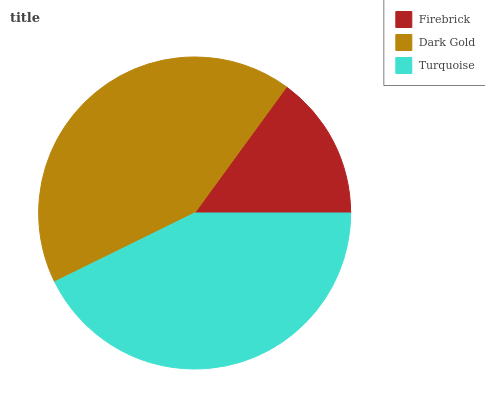Is Firebrick the minimum?
Answer yes or no. Yes. Is Turquoise the maximum?
Answer yes or no. Yes. Is Dark Gold the minimum?
Answer yes or no. No. Is Dark Gold the maximum?
Answer yes or no. No. Is Dark Gold greater than Firebrick?
Answer yes or no. Yes. Is Firebrick less than Dark Gold?
Answer yes or no. Yes. Is Firebrick greater than Dark Gold?
Answer yes or no. No. Is Dark Gold less than Firebrick?
Answer yes or no. No. Is Dark Gold the high median?
Answer yes or no. Yes. Is Dark Gold the low median?
Answer yes or no. Yes. Is Firebrick the high median?
Answer yes or no. No. Is Turquoise the low median?
Answer yes or no. No. 